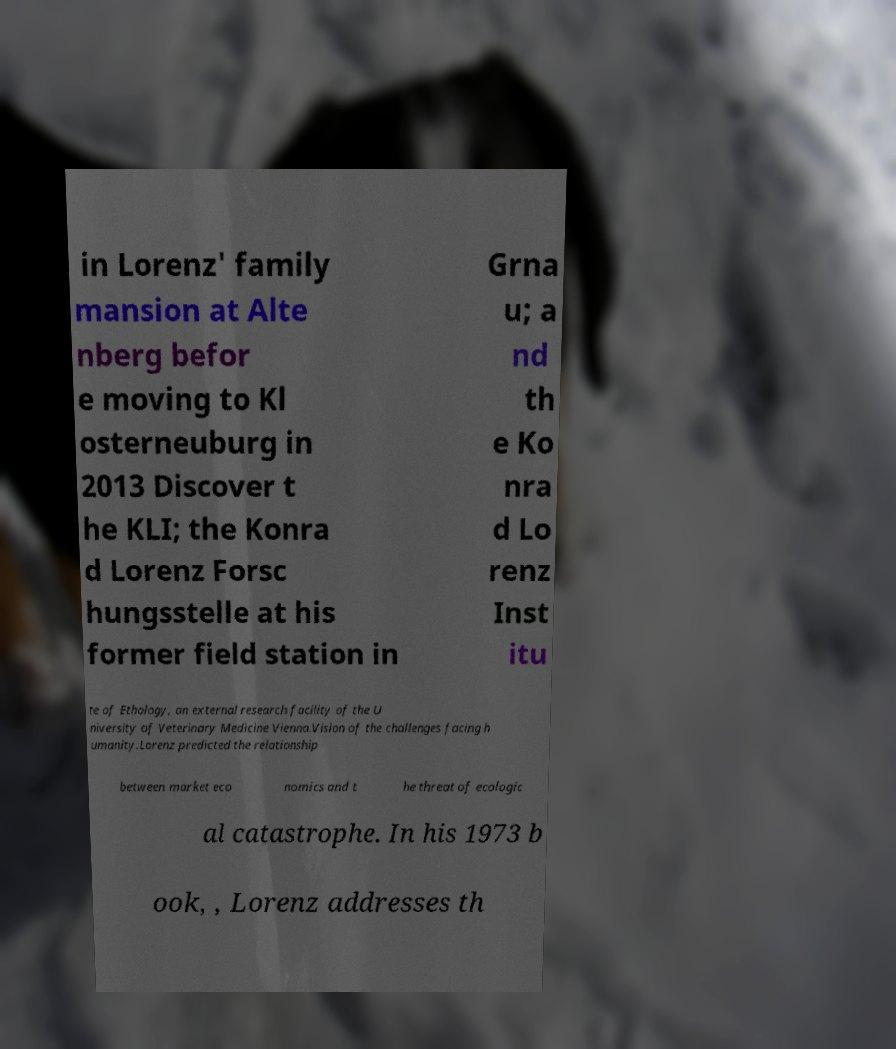Can you accurately transcribe the text from the provided image for me? in Lorenz' family mansion at Alte nberg befor e moving to Kl osterneuburg in 2013 Discover t he KLI; the Konra d Lorenz Forsc hungsstelle at his former field station in Grna u; a nd th e Ko nra d Lo renz Inst itu te of Ethology, an external research facility of the U niversity of Veterinary Medicine Vienna.Vision of the challenges facing h umanity.Lorenz predicted the relationship between market eco nomics and t he threat of ecologic al catastrophe. In his 1973 b ook, , Lorenz addresses th 